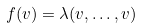<formula> <loc_0><loc_0><loc_500><loc_500>f ( v ) = \lambda ( v , \dots , v )</formula> 